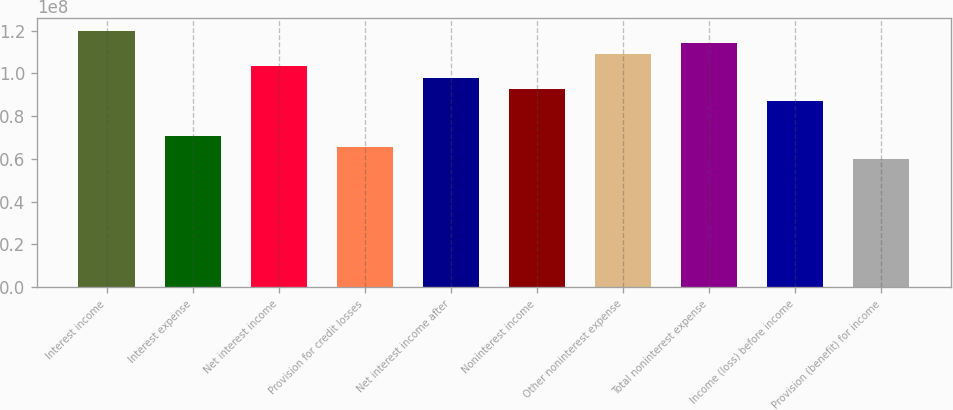<chart> <loc_0><loc_0><loc_500><loc_500><bar_chart><fcel>Interest income<fcel>Interest expense<fcel>Net interest income<fcel>Provision for credit losses<fcel>Net interest income after<fcel>Noninterest income<fcel>Other noninterest expense<fcel>Total noninterest expense<fcel>Income (loss) before income<fcel>Provision (benefit) for income<nl><fcel>1.19791e+08<fcel>7.07858e+07<fcel>1.03456e+08<fcel>6.53408e+07<fcel>9.80112e+07<fcel>9.25661e+07<fcel>1.08901e+08<fcel>1.14346e+08<fcel>8.7121e+07<fcel>5.98957e+07<nl></chart> 